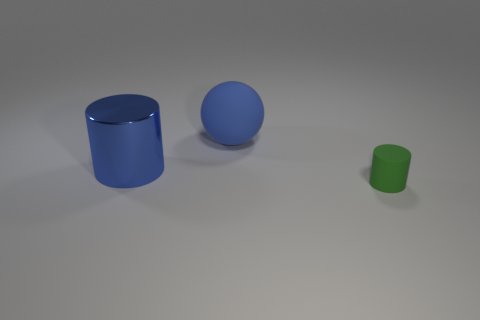Can you describe the lighting in the scene? The scene is softly illuminated with what seems to be a diffuse light source casting gentle shadows on the right side of the objects, suggesting the light is coming from the top left. The lighting gives the scene a calm and even look without harsh contrasts. 